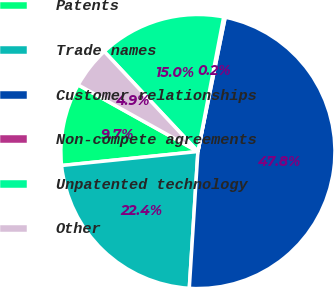Convert chart. <chart><loc_0><loc_0><loc_500><loc_500><pie_chart><fcel>Patents<fcel>Trade names<fcel>Customer relationships<fcel>Non-compete agreements<fcel>Unpatented technology<fcel>Other<nl><fcel>9.71%<fcel>22.37%<fcel>47.81%<fcel>0.18%<fcel>14.99%<fcel>4.94%<nl></chart> 